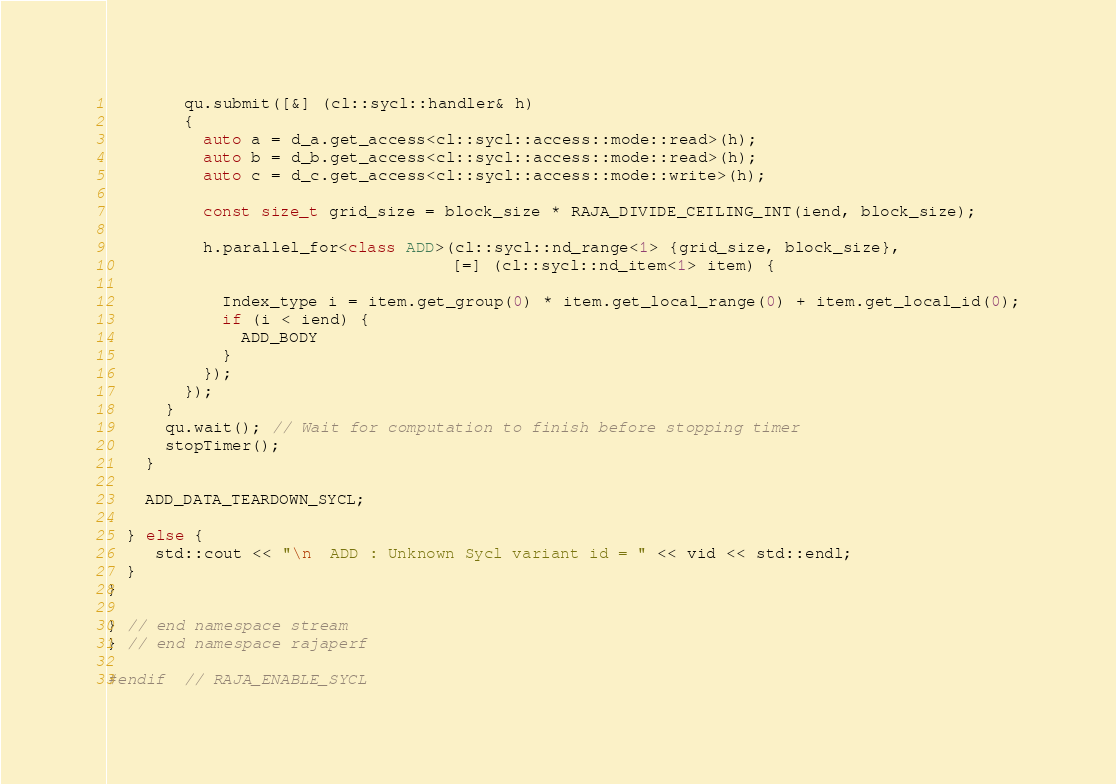<code> <loc_0><loc_0><loc_500><loc_500><_C++_>        qu.submit([&] (cl::sycl::handler& h)
        {
          auto a = d_a.get_access<cl::sycl::access::mode::read>(h);
          auto b = d_b.get_access<cl::sycl::access::mode::read>(h);
          auto c = d_c.get_access<cl::sycl::access::mode::write>(h);

          const size_t grid_size = block_size * RAJA_DIVIDE_CEILING_INT(iend, block_size);

          h.parallel_for<class ADD>(cl::sycl::nd_range<1> {grid_size, block_size},
                                    [=] (cl::sycl::nd_item<1> item) {

            Index_type i = item.get_group(0) * item.get_local_range(0) + item.get_local_id(0);
            if (i < iend) {
              ADD_BODY
            }
          });
        });
      }
      qu.wait(); // Wait for computation to finish before stopping timer
      stopTimer();
    }

    ADD_DATA_TEARDOWN_SYCL;

  } else {
     std::cout << "\n  ADD : Unknown Sycl variant id = " << vid << std::endl;
  }
}

} // end namespace stream
} // end namespace rajaperf

#endif  // RAJA_ENABLE_SYCL
</code> 